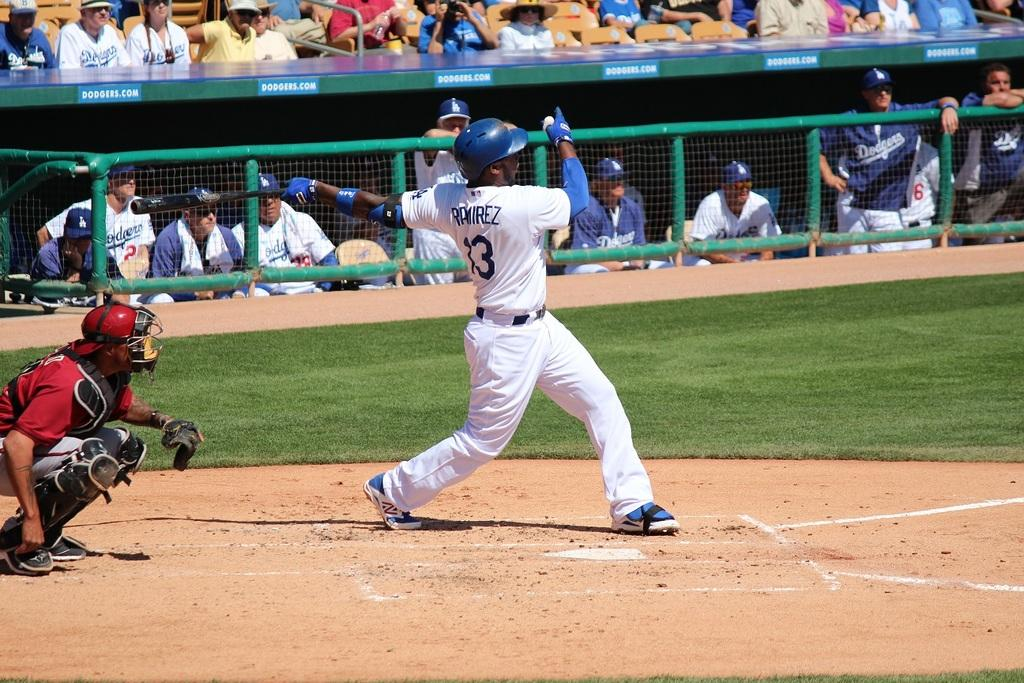Provide a one-sentence caption for the provided image. The stadium the players are in is advertised at dodgers.com. 